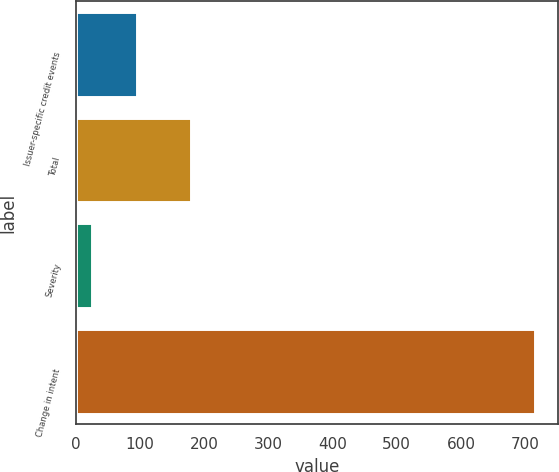Convert chart to OTSL. <chart><loc_0><loc_0><loc_500><loc_500><bar_chart><fcel>Issuer-specific credit events<fcel>Total<fcel>Severity<fcel>Change in intent<nl><fcel>94.9<fcel>179<fcel>26<fcel>715<nl></chart> 